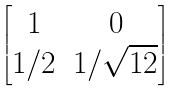<formula> <loc_0><loc_0><loc_500><loc_500>\begin{bmatrix} 1 & 0 \\ 1 / 2 & 1 / \sqrt { 1 2 } \end{bmatrix}</formula> 